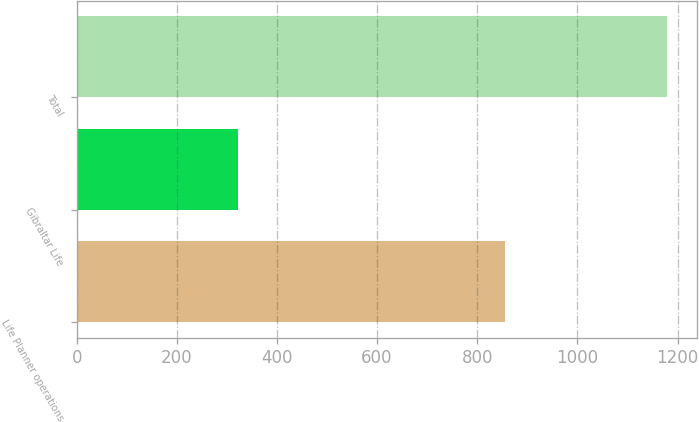Convert chart. <chart><loc_0><loc_0><loc_500><loc_500><bar_chart><fcel>Life Planner operations<fcel>Gibraltar Life<fcel>Total<nl><fcel>856<fcel>323<fcel>1179<nl></chart> 